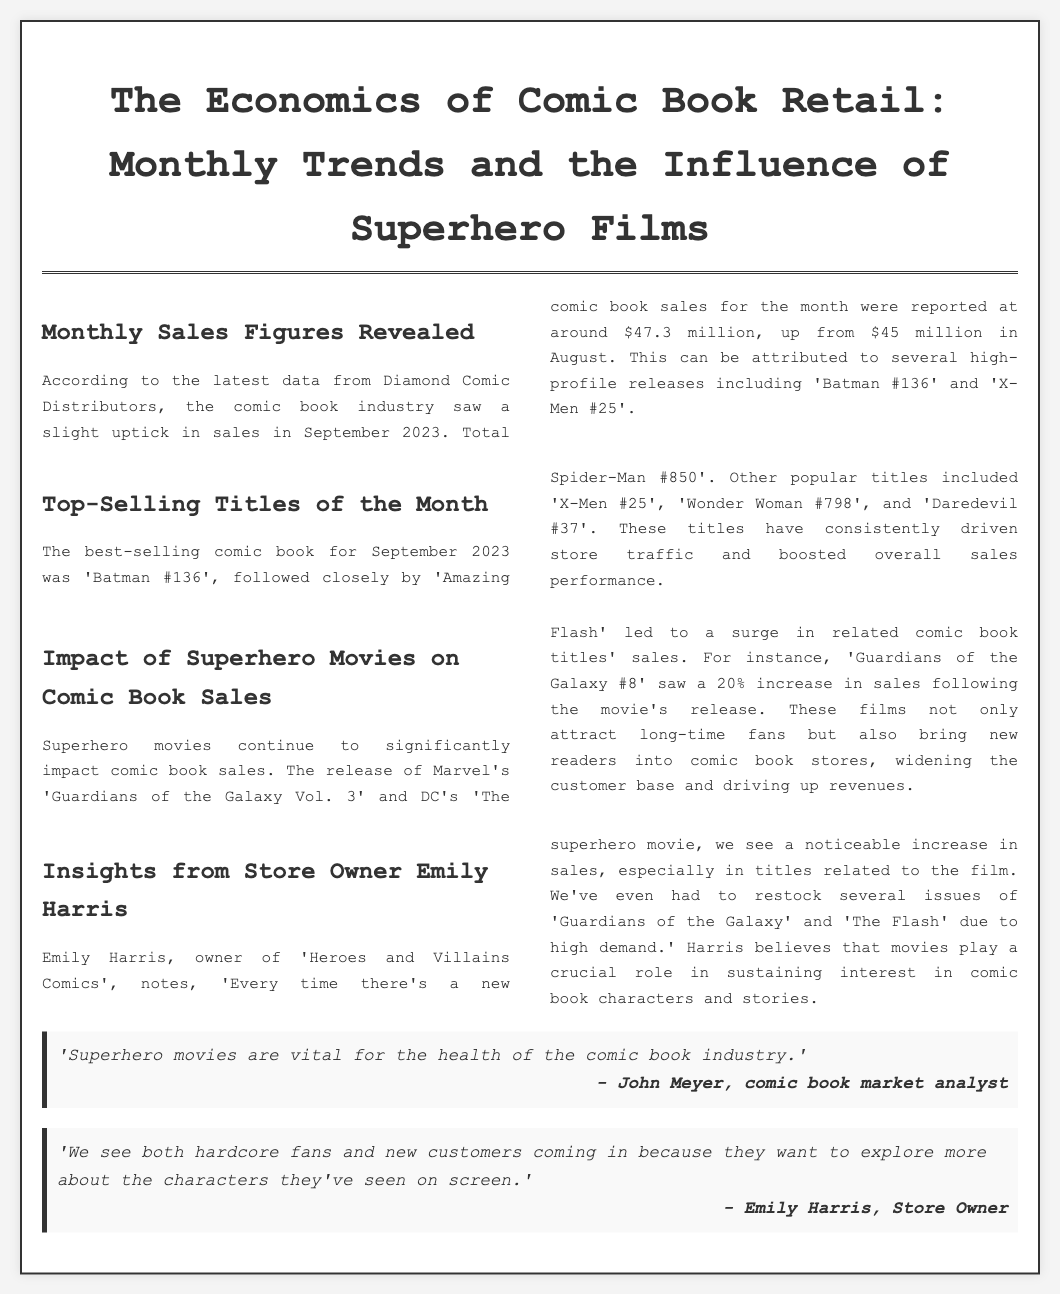what were the total comic book sales for September 2023? The document states that total comic book sales for the month were reported at around $47.3 million.
Answer: $47.3 million what was the best-selling comic book of September 2023? According to the document, the best-selling comic book for September 2023 was 'Batman #136'.
Answer: 'Batman #136' which superhero movie led to a surge in related comic book title sales? The document mentions the release of Marvel's 'Guardians of the Galaxy Vol. 3' as contributing to increased sales.
Answer: 'Guardians of the Galaxy Vol. 3' how much did 'Guardians of the Galaxy #8' sales increase after the movie's release? It is stated that 'Guardians of the Galaxy #8' saw a 20% increase in sales following the movie's release.
Answer: 20% who is the owner of 'Heroes and Villains Comics'? The document identifies Emily Harris as the owner of 'Heroes and Villains Comics'.
Answer: Emily Harris what does Emily Harris believe about superhero movies? Emily Harris believes that superhero movies play a crucial role in sustaining interest in comic book characters and stories.
Answer: they play a crucial role how do superhero movies affect the customer base in comic book stores? The document explains that superhero movies attract long-time fans and bring new readers into comic book stores.
Answer: widen the customer base what trend is observed when a new superhero movie is released? The document notes that there is a noticeable increase in sales every time there's a new superhero movie.
Answer: noticeable increase in sales what is the main topic of the newspaper article? The main topic revolves around the economics of comic book retail, including sales figures and the impact of superhero films.
Answer: The Economics of Comic Book Retail 